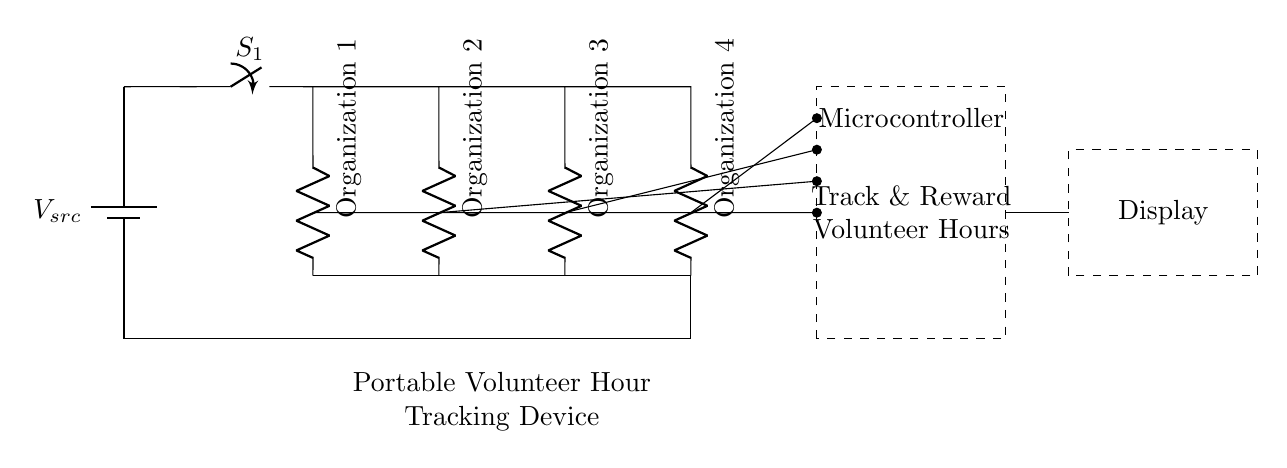What type of circuit is depicted? This circuit is a parallel circuit because multiple branches exist that are connected across the same two nodes, allowing for multiple paths for the current to flow.
Answer: Parallel What is the role of the battery in the circuit? The battery serves as the power source, providing the necessary voltage to drive the current through the circuit.
Answer: Power source How many organizations can be tracked by this device? The circuit diagram shows four resistors, each labeled as an organization, indicating that it can track four different organizations.
Answer: Four What component collects data on volunteer hours? The microcontroller is the component that collects and processes data regarding the volunteer hours from the branches connected.
Answer: Microcontroller Why does this circuit use a parallel configuration? Using a parallel configuration allows each organization to operate independently; if one branch fails, the others continue to function, ensuring reliability.
Answer: Reliability What connects the branches to the microcontroller? Each branch is connected to the microcontroller via short connections, allowing the microcontroller to monitor the current flowing through each organization.
Answer: Short connections 